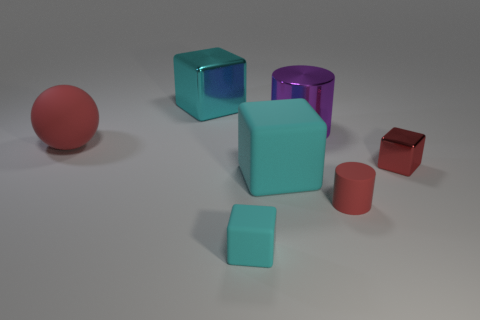What color is the cube that is behind the shiny cube that is in front of the big shiny block?
Provide a succinct answer. Cyan. Is the small matte cylinder the same color as the tiny shiny object?
Keep it short and to the point. Yes. There is a big cyan block in front of the large block that is behind the large red matte object; what is it made of?
Your answer should be very brief. Rubber. There is a tiny red object that is the same shape as the cyan shiny object; what is it made of?
Offer a terse response. Metal. Are there any tiny cubes on the left side of the cyan matte cube behind the tiny red thing in front of the red shiny thing?
Offer a very short reply. Yes. What number of other things are the same color as the big matte cube?
Your response must be concise. 2. What number of large things are behind the red shiny block and to the right of the red ball?
Offer a very short reply. 2. The small cyan rubber object has what shape?
Make the answer very short. Cube. How many other objects are the same material as the large red ball?
Keep it short and to the point. 3. There is a large block that is in front of the big cyan cube that is behind the large thing that is to the left of the cyan metal thing; what is its color?
Give a very brief answer. Cyan. 